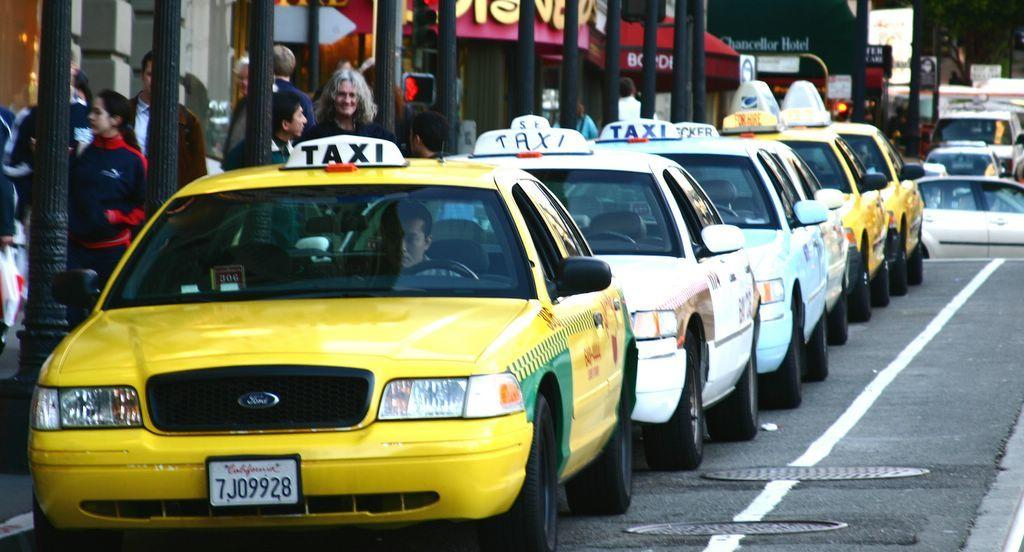<image>
Summarize the visual content of the image. A line of Taxis with the car in front showing a California license plate 